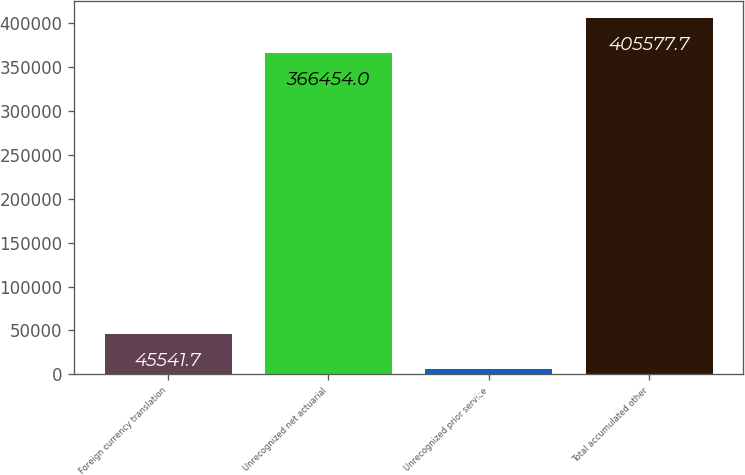Convert chart to OTSL. <chart><loc_0><loc_0><loc_500><loc_500><bar_chart><fcel>Foreign currency translation<fcel>Unrecognized net actuarial<fcel>Unrecognized prior service<fcel>Total accumulated other<nl><fcel>45541.7<fcel>366454<fcel>6418<fcel>405578<nl></chart> 